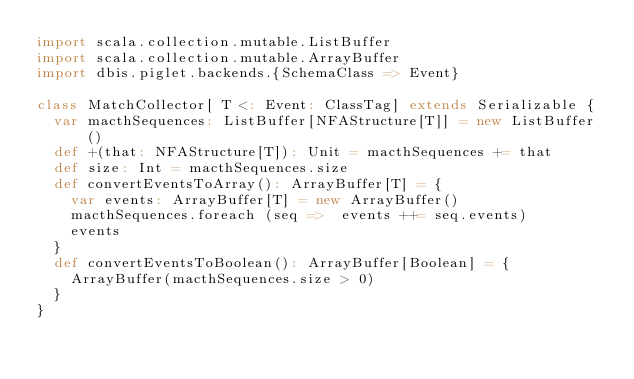Convert code to text. <code><loc_0><loc_0><loc_500><loc_500><_Scala_>import scala.collection.mutable.ListBuffer
import scala.collection.mutable.ArrayBuffer
import dbis.piglet.backends.{SchemaClass => Event}

class MatchCollector[ T <: Event: ClassTag] extends Serializable {
  var macthSequences: ListBuffer[NFAStructure[T]] = new ListBuffer()
  def +(that: NFAStructure[T]): Unit = macthSequences += that
  def size: Int = macthSequences.size
  def convertEventsToArray(): ArrayBuffer[T] = {
    var events: ArrayBuffer[T] = new ArrayBuffer()
    macthSequences.foreach (seq =>  events ++= seq.events)
    events
  }
  def convertEventsToBoolean(): ArrayBuffer[Boolean] = {
    ArrayBuffer(macthSequences.size > 0)
  }
}</code> 